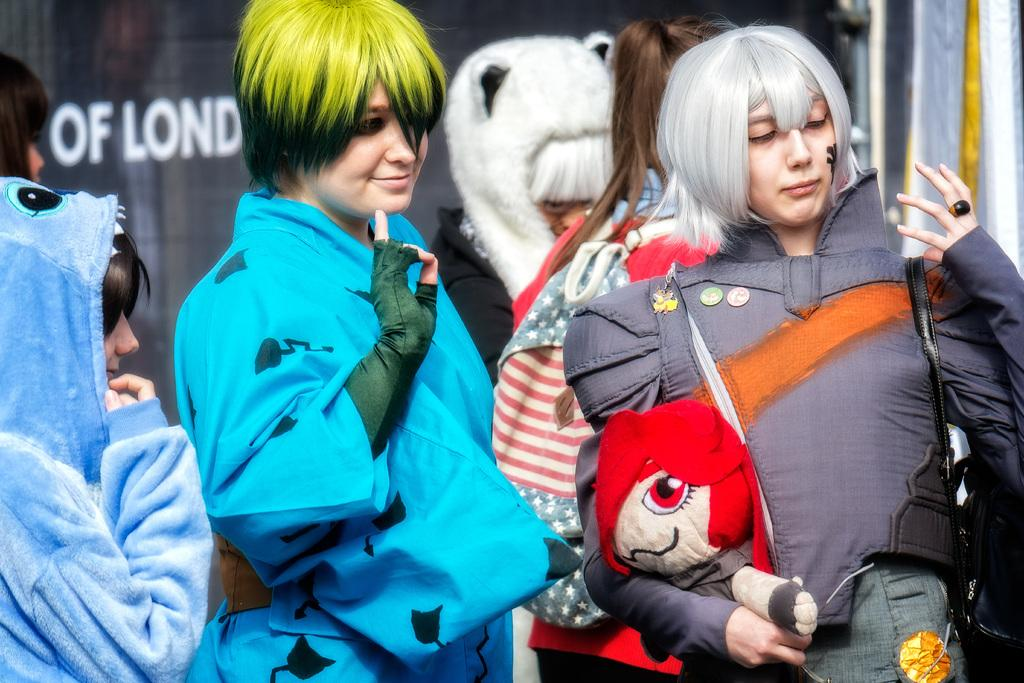What can be seen in the image? There is a group of women in the image. What are the women wearing? The women are wearing different cosplay costumes. Where are the women located? The women are present over a place. What expression do the women have? All the women are smiling. What type of care can be seen being provided to the crow in the image? There is no crow present in the image, and therefore no care is being provided. What is the women using to rake the leaves in the image? There are no leaves or rakes present in the image. 